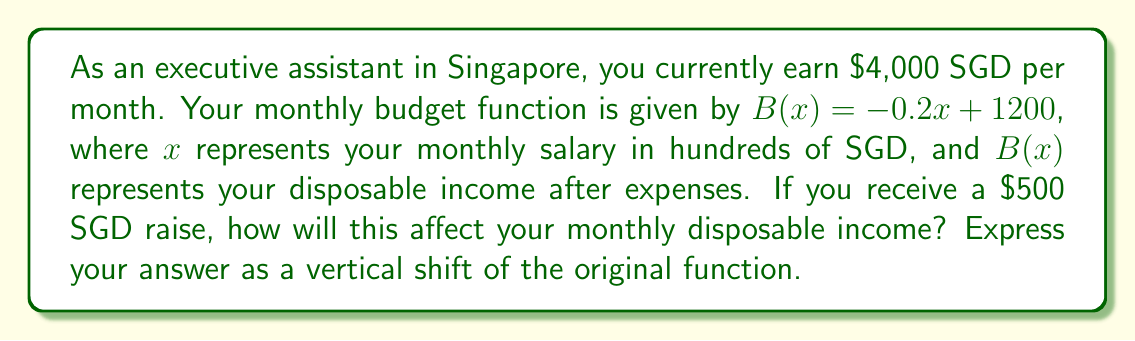What is the answer to this math problem? To solve this problem, we need to understand how a change in salary affects the budget function through a vertical shift. Let's break it down step-by-step:

1) First, let's identify the current situation:
   - Current salary: $4,000 SGD = 40 hundred SGD
   - Current budget function: $B(x) = -0.2x + 1200$

2) Calculate the current disposable income:
   $B(40) = -0.2(40) + 1200 = -8 + 1200 = 1192$ SGD

3) Now, consider the salary increase:
   - New salary: $4,000 + 500 = 4,500 SGD = 45 hundred SGD

4) To represent this change as a vertical shift, we need to calculate how much the disposable income changes:
   
   New disposable income: $B(45) = -0.2(45) + 1200 = -9 + 1200 = 1191$ SGD

5) The change in disposable income is:
   $1191 - 1192 = -1$ SGD

6) This means that despite the salary increase, the disposable income actually decreases by 1 SGD due to the negative slope of the budget function (representing higher expenses with higher income).

7) To express this as a vertical shift of the original function, we add the change to the constant term:
   
   New function: $B_{new}(x) = -0.2x + 1200 - 1 = -0.2x + 1199$

This represents a vertical shift of 1 unit downward.
Answer: The salary increase results in a vertical shift of the budget function by 1 unit downward, represented by $B_{new}(x) = -0.2x + 1199$. 